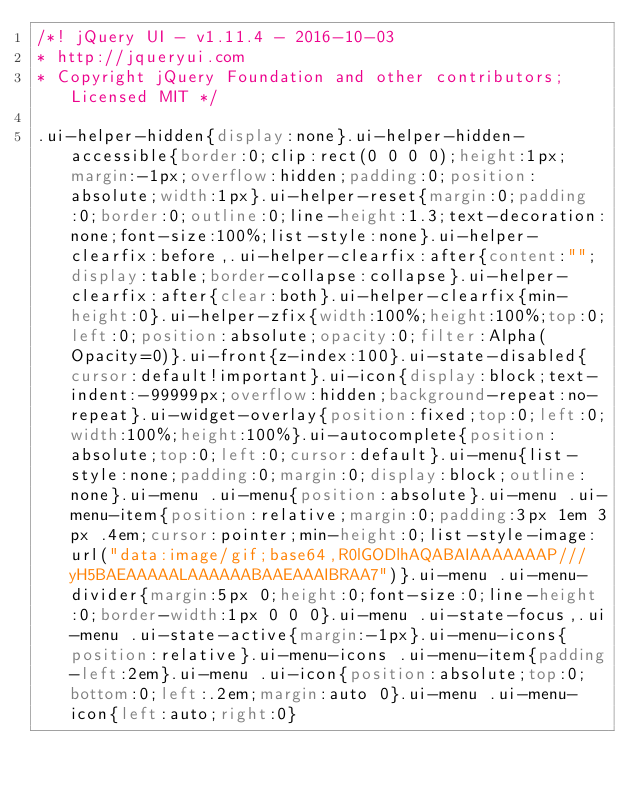Convert code to text. <code><loc_0><loc_0><loc_500><loc_500><_CSS_>/*! jQuery UI - v1.11.4 - 2016-10-03
* http://jqueryui.com
* Copyright jQuery Foundation and other contributors; Licensed MIT */

.ui-helper-hidden{display:none}.ui-helper-hidden-accessible{border:0;clip:rect(0 0 0 0);height:1px;margin:-1px;overflow:hidden;padding:0;position:absolute;width:1px}.ui-helper-reset{margin:0;padding:0;border:0;outline:0;line-height:1.3;text-decoration:none;font-size:100%;list-style:none}.ui-helper-clearfix:before,.ui-helper-clearfix:after{content:"";display:table;border-collapse:collapse}.ui-helper-clearfix:after{clear:both}.ui-helper-clearfix{min-height:0}.ui-helper-zfix{width:100%;height:100%;top:0;left:0;position:absolute;opacity:0;filter:Alpha(Opacity=0)}.ui-front{z-index:100}.ui-state-disabled{cursor:default!important}.ui-icon{display:block;text-indent:-99999px;overflow:hidden;background-repeat:no-repeat}.ui-widget-overlay{position:fixed;top:0;left:0;width:100%;height:100%}.ui-autocomplete{position:absolute;top:0;left:0;cursor:default}.ui-menu{list-style:none;padding:0;margin:0;display:block;outline:none}.ui-menu .ui-menu{position:absolute}.ui-menu .ui-menu-item{position:relative;margin:0;padding:3px 1em 3px .4em;cursor:pointer;min-height:0;list-style-image:url("data:image/gif;base64,R0lGODlhAQABAIAAAAAAAP///yH5BAEAAAAALAAAAAABAAEAAAIBRAA7")}.ui-menu .ui-menu-divider{margin:5px 0;height:0;font-size:0;line-height:0;border-width:1px 0 0 0}.ui-menu .ui-state-focus,.ui-menu .ui-state-active{margin:-1px}.ui-menu-icons{position:relative}.ui-menu-icons .ui-menu-item{padding-left:2em}.ui-menu .ui-icon{position:absolute;top:0;bottom:0;left:.2em;margin:auto 0}.ui-menu .ui-menu-icon{left:auto;right:0}</code> 